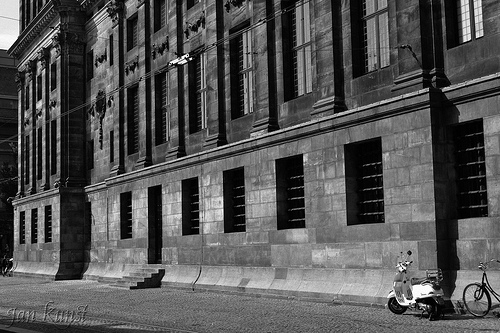Is there any bag or bicycle in this photo? Yes, there is a bicycle in the photo. 